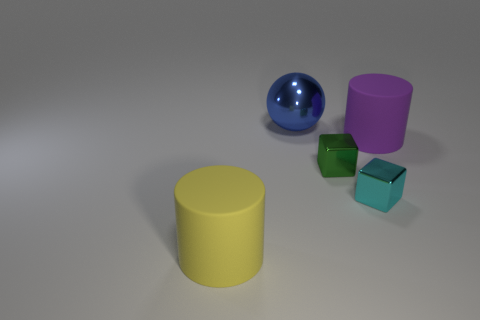Is the color of the cylinder that is to the right of the large blue thing the same as the big thing that is in front of the cyan metal cube?
Provide a short and direct response. No. How many green blocks are the same size as the cyan cube?
Make the answer very short. 1. Does the object that is to the left of the blue metal thing have the same size as the purple object?
Your response must be concise. Yes. The small green thing has what shape?
Make the answer very short. Cube. Is the material of the large cylinder that is left of the green metallic thing the same as the small cyan thing?
Keep it short and to the point. No. Is there a big matte cylinder that has the same color as the big shiny thing?
Ensure brevity in your answer.  No. There is a large rubber object on the left side of the cyan thing; does it have the same shape as the large thing to the right of the large blue metal ball?
Provide a short and direct response. Yes. Are there any purple objects that have the same material as the tiny green thing?
Offer a terse response. No. How many green things are tiny things or cylinders?
Offer a very short reply. 1. What is the size of the object that is both left of the tiny cyan metallic object and right of the large blue metallic object?
Keep it short and to the point. Small. 